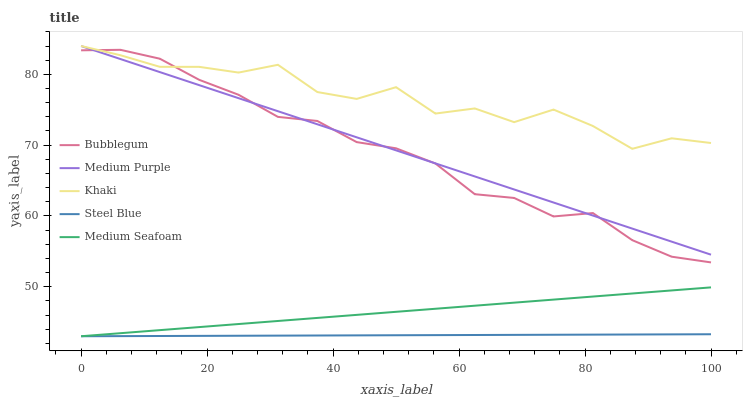Does Steel Blue have the minimum area under the curve?
Answer yes or no. Yes. Does Khaki have the maximum area under the curve?
Answer yes or no. Yes. Does Khaki have the minimum area under the curve?
Answer yes or no. No. Does Steel Blue have the maximum area under the curve?
Answer yes or no. No. Is Medium Purple the smoothest?
Answer yes or no. Yes. Is Khaki the roughest?
Answer yes or no. Yes. Is Steel Blue the smoothest?
Answer yes or no. No. Is Steel Blue the roughest?
Answer yes or no. No. Does Khaki have the lowest value?
Answer yes or no. No. Does Steel Blue have the highest value?
Answer yes or no. No. Is Steel Blue less than Medium Purple?
Answer yes or no. Yes. Is Bubblegum greater than Medium Seafoam?
Answer yes or no. Yes. Does Steel Blue intersect Medium Purple?
Answer yes or no. No. 